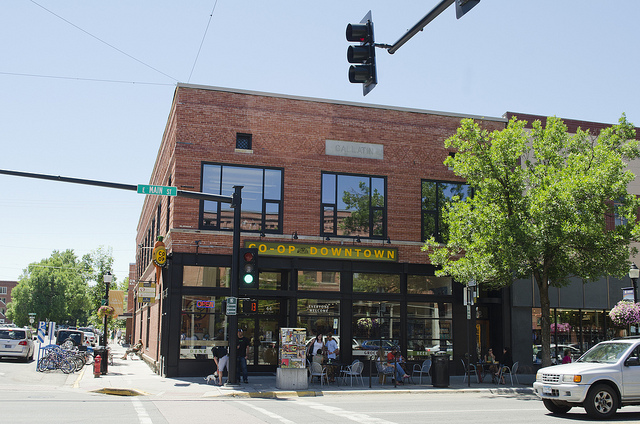<image>What brand name is prominently featured in this photo? I am unsure. It can be 'none' or 'co op downtown'. What is the name of the bank? It is unclear what the name of the bank is, it could potentially be 'co op downtown', 'bop' or there may not be a bank. What color is the traffic light? I don't know what color the traffic light is. It could be either green or red. What is the name of the bank? The name of the bank is Co Op Downtown. What brand name is prominently featured in this photo? I'm not sure what brand name is prominently featured in this photo. It can be seen as 'co op downtown' or 'coop downtown'. What color is the traffic light? I am not sure what color is the traffic light. It can be seen both green and red. 